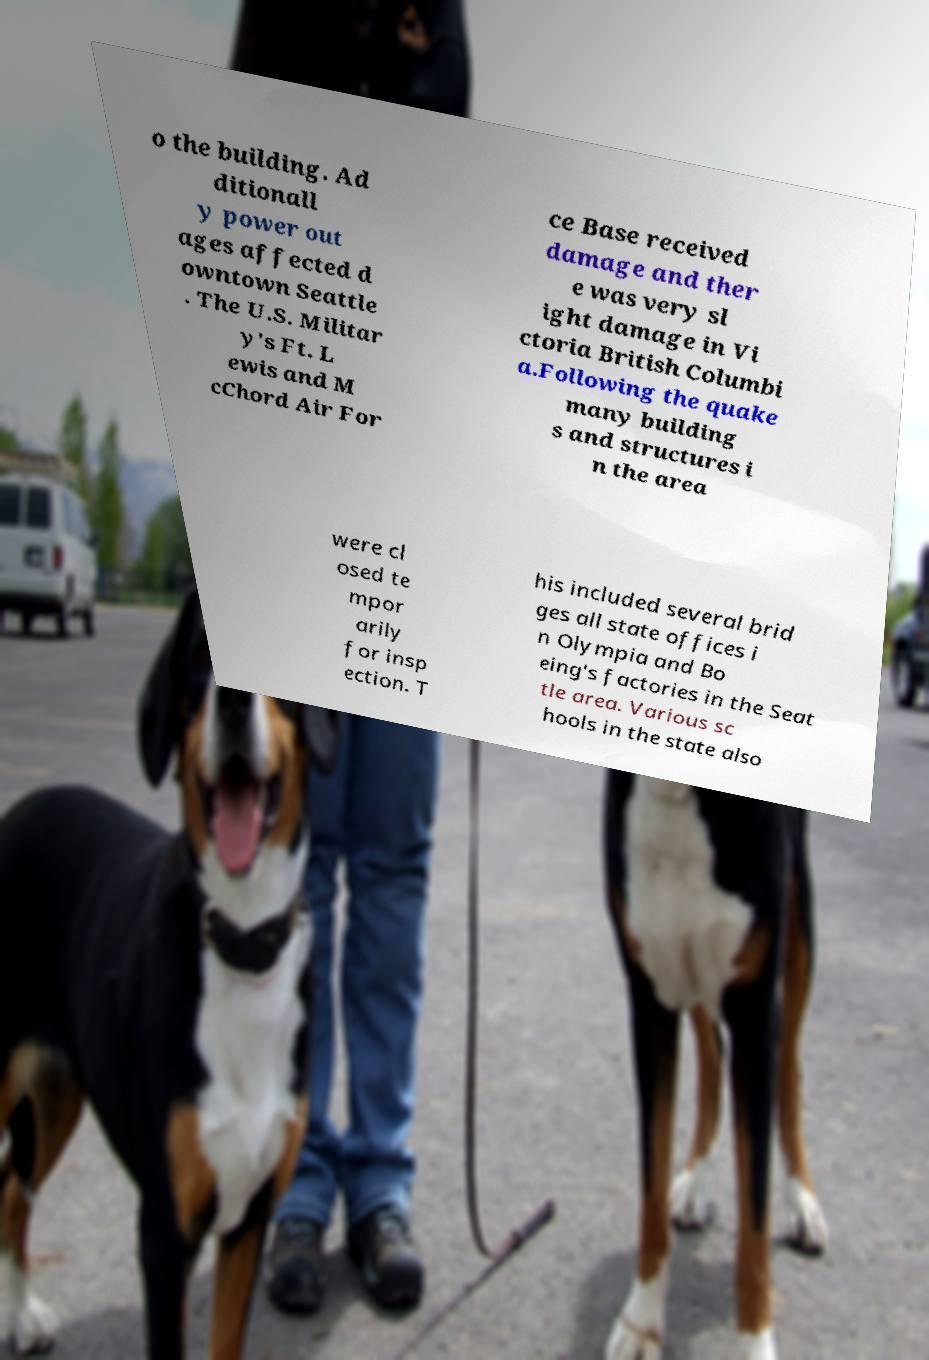Please identify and transcribe the text found in this image. o the building. Ad ditionall y power out ages affected d owntown Seattle . The U.S. Militar y's Ft. L ewis and M cChord Air For ce Base received damage and ther e was very sl ight damage in Vi ctoria British Columbi a.Following the quake many building s and structures i n the area were cl osed te mpor arily for insp ection. T his included several brid ges all state offices i n Olympia and Bo eing's factories in the Seat tle area. Various sc hools in the state also 